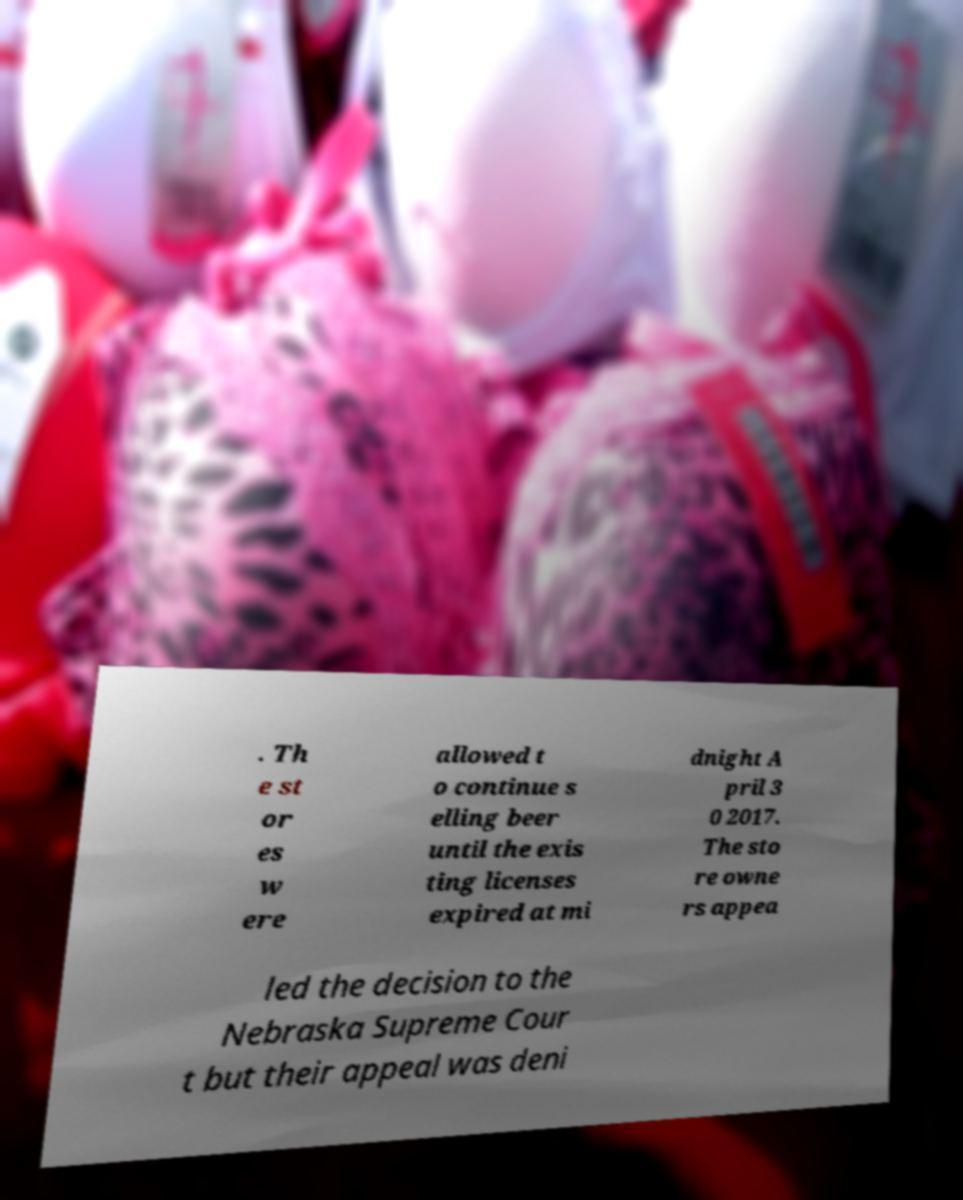What messages or text are displayed in this image? I need them in a readable, typed format. . Th e st or es w ere allowed t o continue s elling beer until the exis ting licenses expired at mi dnight A pril 3 0 2017. The sto re owne rs appea led the decision to the Nebraska Supreme Cour t but their appeal was deni 